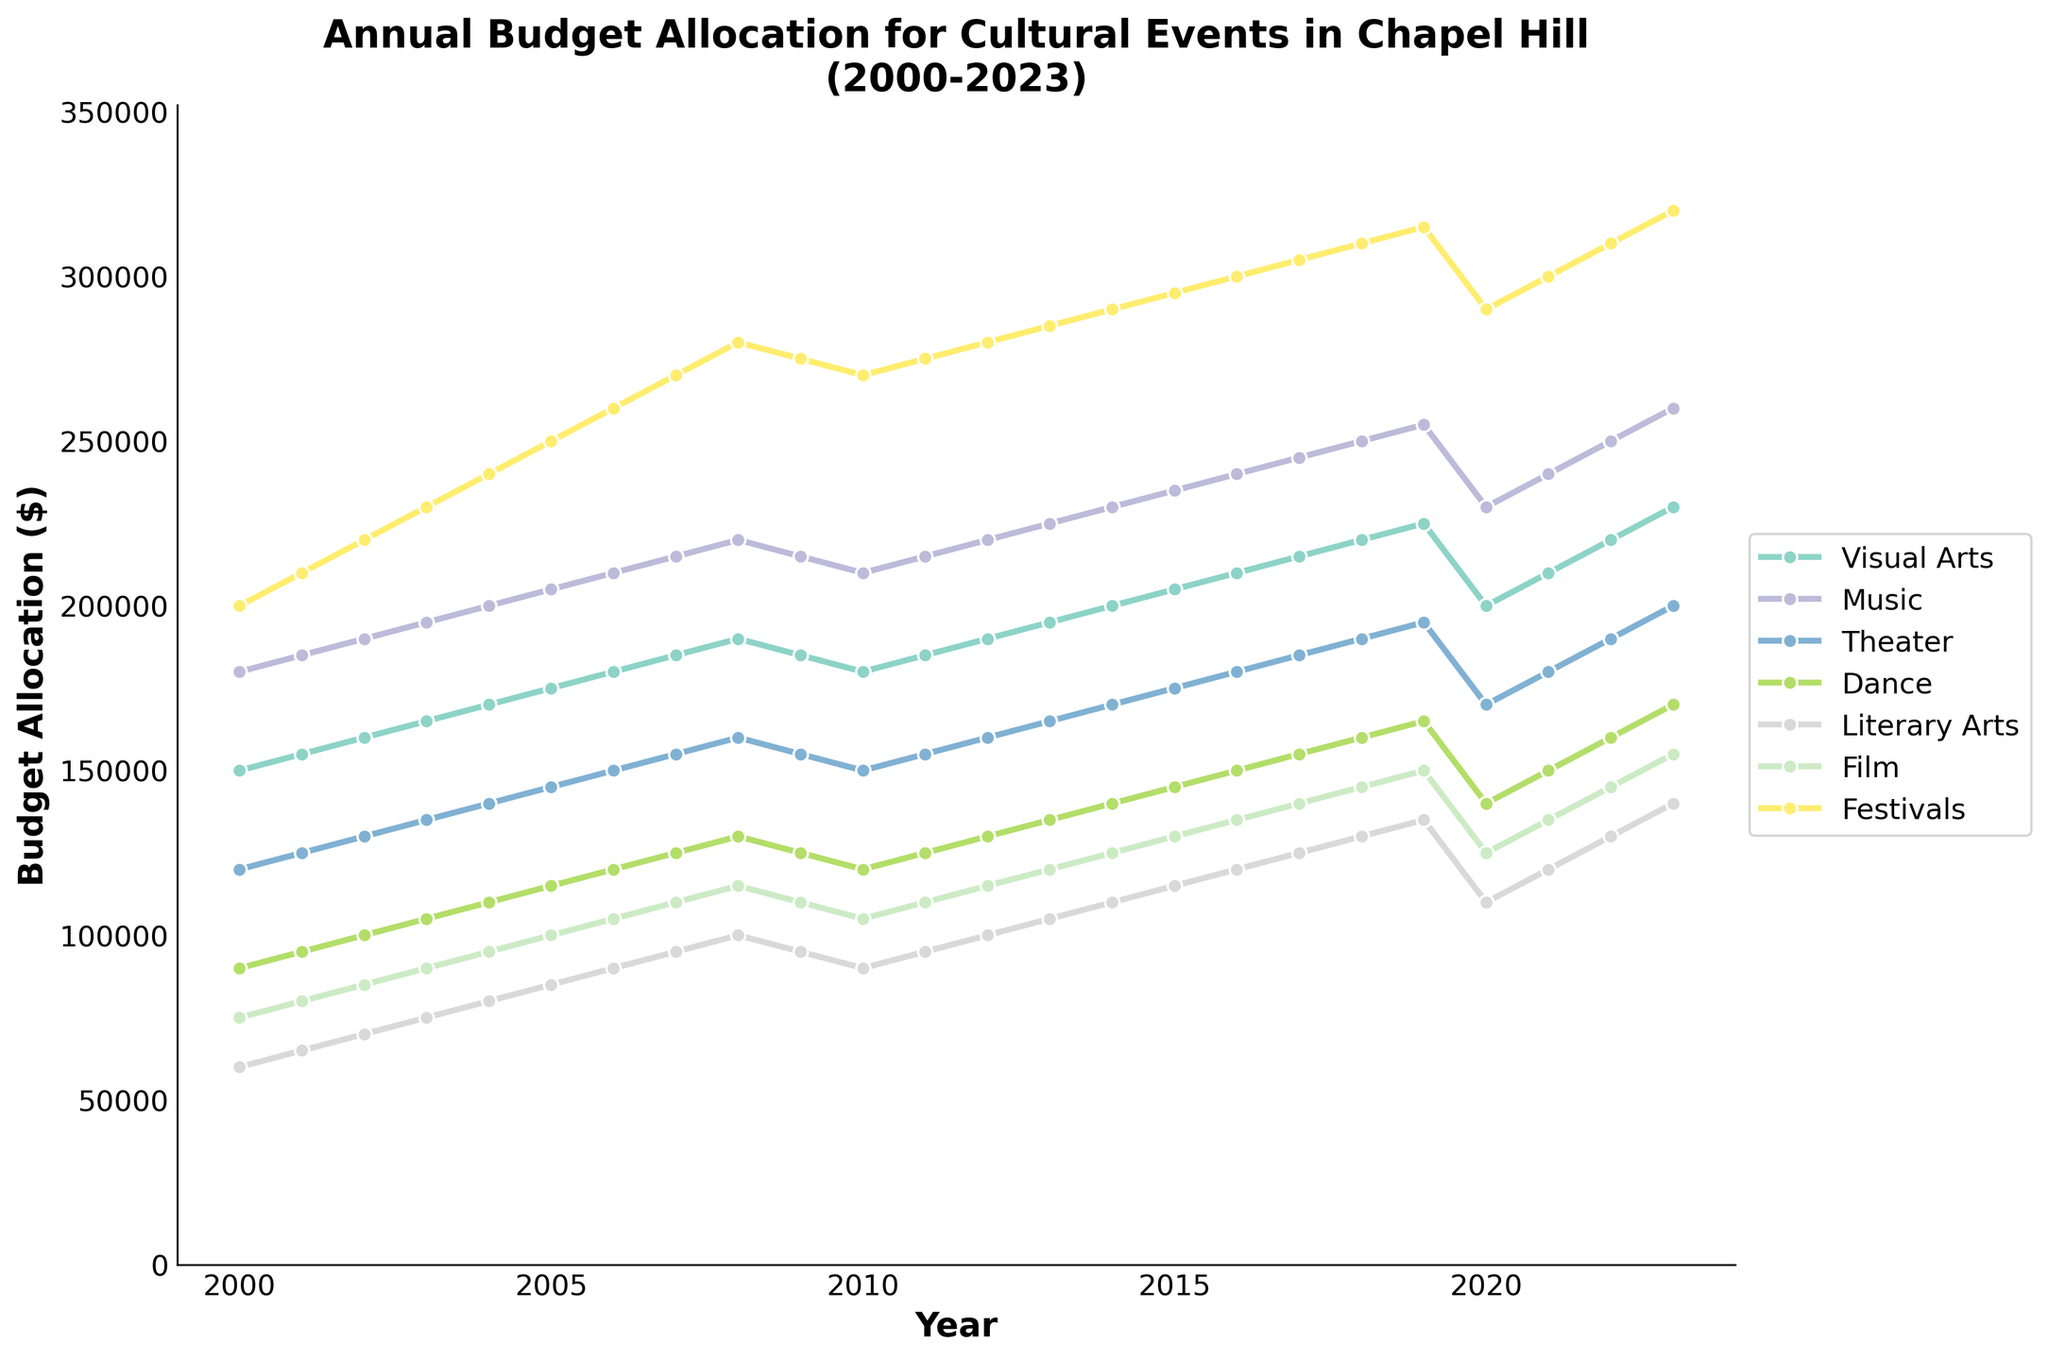what was the budget allocation for Visual Arts in 2023? Look for the point on the line representing Visual Arts in 2023 on the chart and read the value.
Answer: $230,000 Between which years did Music see the largest increase in budget allocation? Identify the straightest and steepest upward slope on the Music line graph and note the corresponding years.
Answer: 2018 to 2019 Did Theater ever receive a higher budget than Visual Arts between 2000 and 2023? Compare the lines representing Theater and Visual Arts across the years, checking if Theater's line was ever above Visual Arts'.
Answer: No In which year did Dance have a budget lower than $100,000? Trace along the Dance line graph and check the budget values corresponding to each year.
Answer: 2000 Which art form received the highest budget allocation in 2005? Observe the peak values of all lines corresponding to the year 2005 and identify the highest one.
Answer: Festivals What is the total budget allocation for Literary Arts from 2020 to 2023? Sum the budget values for Literary Arts from 2020, 2021, 2022, and 2023. The numbers are $110,000, $120,000, $130,000, and $140,000 respectively.
Answer: $500,000 Compare the budget allocation for Film in 2019 and 2020. Which year had a higher budget, and by how much? Check the line points for Film in 2019 and 2020. The values are $150,000 for 2019 and $125,000 for 2020. Subtract to find the difference.
Answer: 2019, by $25,000 What colors are used to represent Music and Festivals in the chart? Visually inspect the color of the lines representing Music and Festivals.
Answer: Music is represented by green, Festivals by pink How did the budget for Festivals change between 2019 and 2020, and what could this indicate? Look at the points on the Festivals line for 2019 and 2020; notice any trend. The budget was $315,000 in 2019 and $290,000 in 2020, indicating a decrease.
Answer: It decreased, indicating a possible cut in funding 